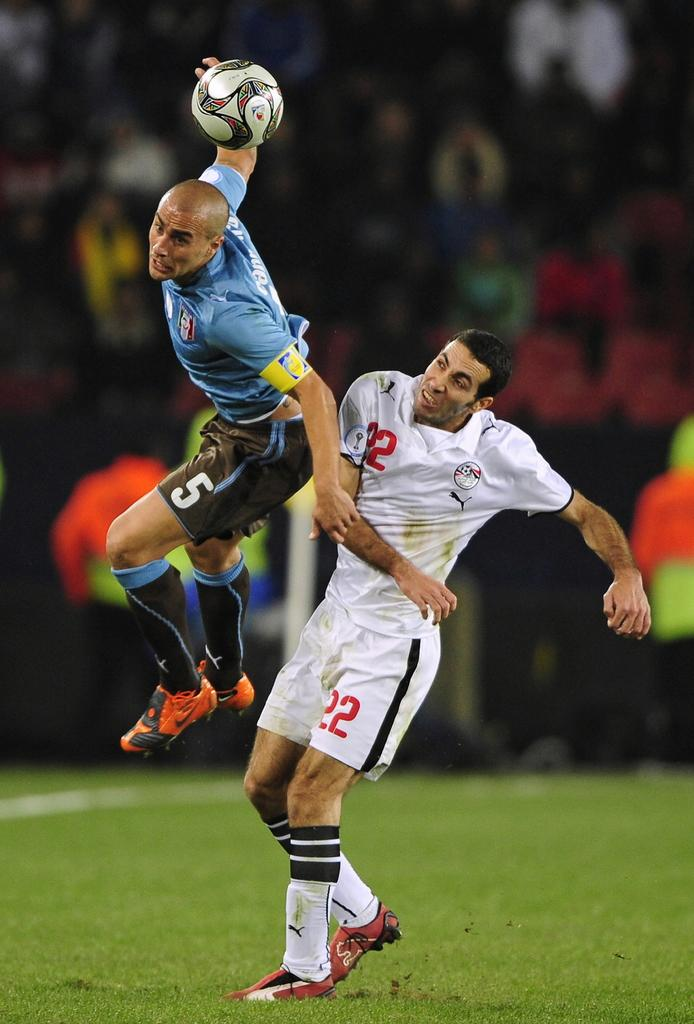How many people are in the image? There are two men in the image. What is the position of one of the men? One man is in the air. Where is the other man located? The other man is on the grass. What object can be seen in the image? There is a ball in the image. What type of silk fabric is draped over the man on the grass? There is no silk fabric present in the image; the man on the grass is not wearing or holding any fabric. 